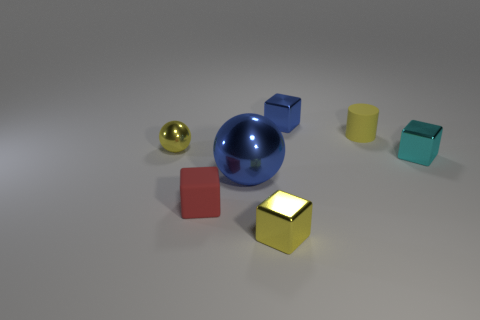Subtract all yellow shiny cubes. How many cubes are left? 3 Subtract all red cubes. How many cubes are left? 3 Add 3 tiny yellow blocks. How many objects exist? 10 Subtract 1 cubes. How many cubes are left? 3 Subtract all red cubes. Subtract all brown balls. How many cubes are left? 3 Subtract all cylinders. How many objects are left? 6 Add 4 yellow cylinders. How many yellow cylinders are left? 5 Add 3 green metal things. How many green metal things exist? 3 Subtract 0 green cylinders. How many objects are left? 7 Subtract all small cylinders. Subtract all metal blocks. How many objects are left? 3 